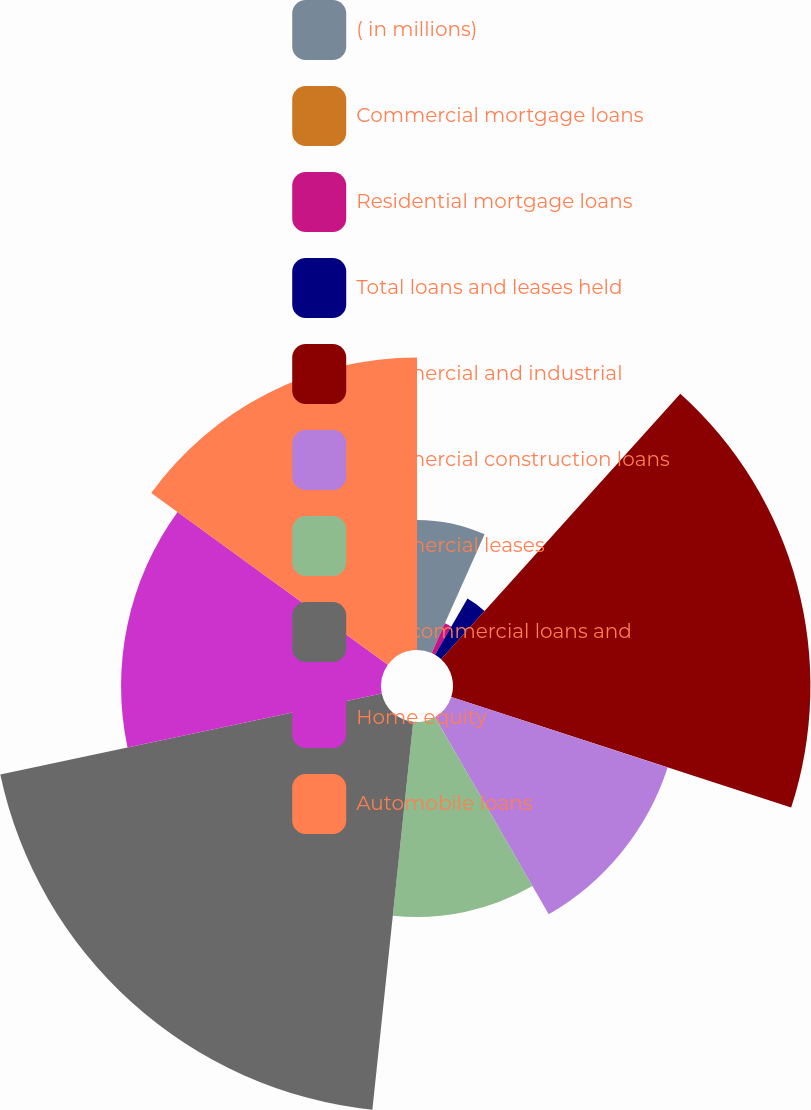Convert chart to OTSL. <chart><loc_0><loc_0><loc_500><loc_500><pie_chart><fcel>( in millions)<fcel>Commercial mortgage loans<fcel>Residential mortgage loans<fcel>Total loans and leases held<fcel>Commercial and industrial<fcel>Commercial construction loans<fcel>Commercial leases<fcel>Total commercial loans and<fcel>Home equity<fcel>Automobile loans<nl><fcel>6.67%<fcel>0.0%<fcel>1.67%<fcel>3.33%<fcel>18.33%<fcel>11.67%<fcel>10.0%<fcel>20.0%<fcel>13.33%<fcel>15.0%<nl></chart> 